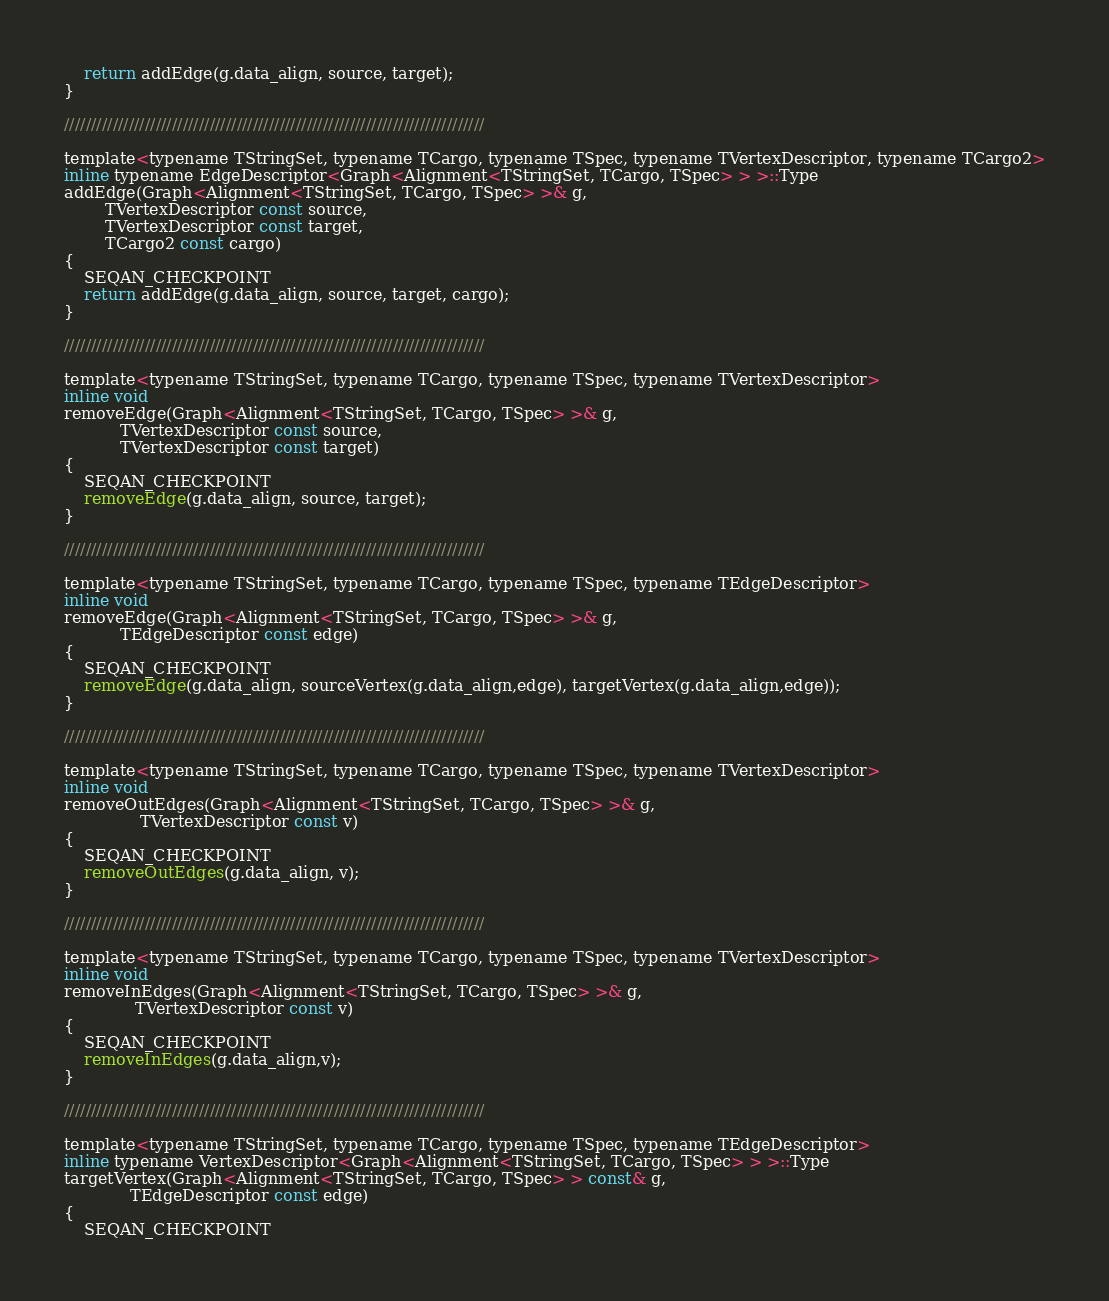Convert code to text. <code><loc_0><loc_0><loc_500><loc_500><_C_>    return addEdge(g.data_align, source, target);
}

//////////////////////////////////////////////////////////////////////////////

template<typename TStringSet, typename TCargo, typename TSpec, typename TVertexDescriptor, typename TCargo2>
inline typename EdgeDescriptor<Graph<Alignment<TStringSet, TCargo, TSpec> > >::Type
addEdge(Graph<Alignment<TStringSet, TCargo, TSpec> >& g,
        TVertexDescriptor const source,
        TVertexDescriptor const target,
        TCargo2 const cargo)
{
    SEQAN_CHECKPOINT
    return addEdge(g.data_align, source, target, cargo);
}

//////////////////////////////////////////////////////////////////////////////

template<typename TStringSet, typename TCargo, typename TSpec, typename TVertexDescriptor>
inline void
removeEdge(Graph<Alignment<TStringSet, TCargo, TSpec> >& g,
           TVertexDescriptor const source,
           TVertexDescriptor const target)
{
    SEQAN_CHECKPOINT
    removeEdge(g.data_align, source, target);
}

//////////////////////////////////////////////////////////////////////////////

template<typename TStringSet, typename TCargo, typename TSpec, typename TEdgeDescriptor>
inline void
removeEdge(Graph<Alignment<TStringSet, TCargo, TSpec> >& g,
           TEdgeDescriptor const edge)
{
    SEQAN_CHECKPOINT
    removeEdge(g.data_align, sourceVertex(g.data_align,edge), targetVertex(g.data_align,edge));
}

//////////////////////////////////////////////////////////////////////////////

template<typename TStringSet, typename TCargo, typename TSpec, typename TVertexDescriptor>
inline void
removeOutEdges(Graph<Alignment<TStringSet, TCargo, TSpec> >& g,
               TVertexDescriptor const v)
{
    SEQAN_CHECKPOINT
    removeOutEdges(g.data_align, v);
}

//////////////////////////////////////////////////////////////////////////////

template<typename TStringSet, typename TCargo, typename TSpec, typename TVertexDescriptor>
inline void
removeInEdges(Graph<Alignment<TStringSet, TCargo, TSpec> >& g,
              TVertexDescriptor const v)
{
    SEQAN_CHECKPOINT
    removeInEdges(g.data_align,v);
}

//////////////////////////////////////////////////////////////////////////////

template<typename TStringSet, typename TCargo, typename TSpec, typename TEdgeDescriptor>
inline typename VertexDescriptor<Graph<Alignment<TStringSet, TCargo, TSpec> > >::Type
targetVertex(Graph<Alignment<TStringSet, TCargo, TSpec> > const& g,
             TEdgeDescriptor const edge)
{
    SEQAN_CHECKPOINT</code> 